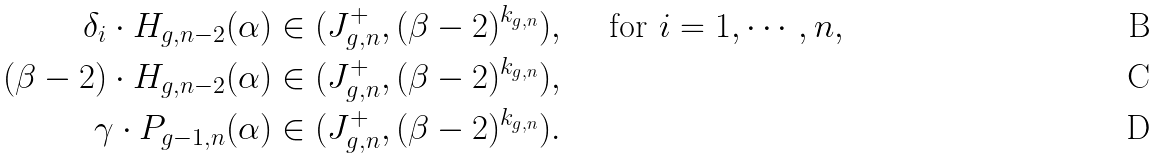<formula> <loc_0><loc_0><loc_500><loc_500>\delta _ { i } \cdot H _ { g , n - 2 } ( \alpha ) & \in ( J ^ { + } _ { g , n } , ( \beta - 2 ) ^ { k _ { g , n } } ) , \quad \text { for } i = 1 , \cdots , n , \\ ( \beta - 2 ) \cdot H _ { g , n - 2 } ( \alpha ) & \in ( J ^ { + } _ { g , n } , ( \beta - 2 ) ^ { k _ { g , n } } ) , \\ \gamma \cdot P _ { g - 1 , n } ( \alpha ) & \in ( J ^ { + } _ { g , n } , ( \beta - 2 ) ^ { k _ { g , n } } ) .</formula> 